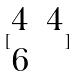<formula> <loc_0><loc_0><loc_500><loc_500>[ \begin{matrix} 4 & 4 \\ 6 \end{matrix} ]</formula> 